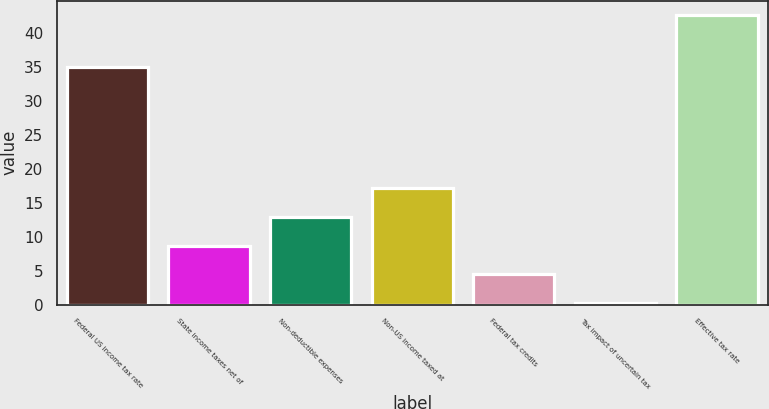<chart> <loc_0><loc_0><loc_500><loc_500><bar_chart><fcel>Federal US income tax rate<fcel>State income taxes net of<fcel>Non-deductible expenses<fcel>Non-US income taxed at<fcel>Federal tax credits<fcel>Tax impact of uncertain tax<fcel>Effective tax rate<nl><fcel>35<fcel>8.68<fcel>12.92<fcel>17.16<fcel>4.44<fcel>0.2<fcel>42.6<nl></chart> 